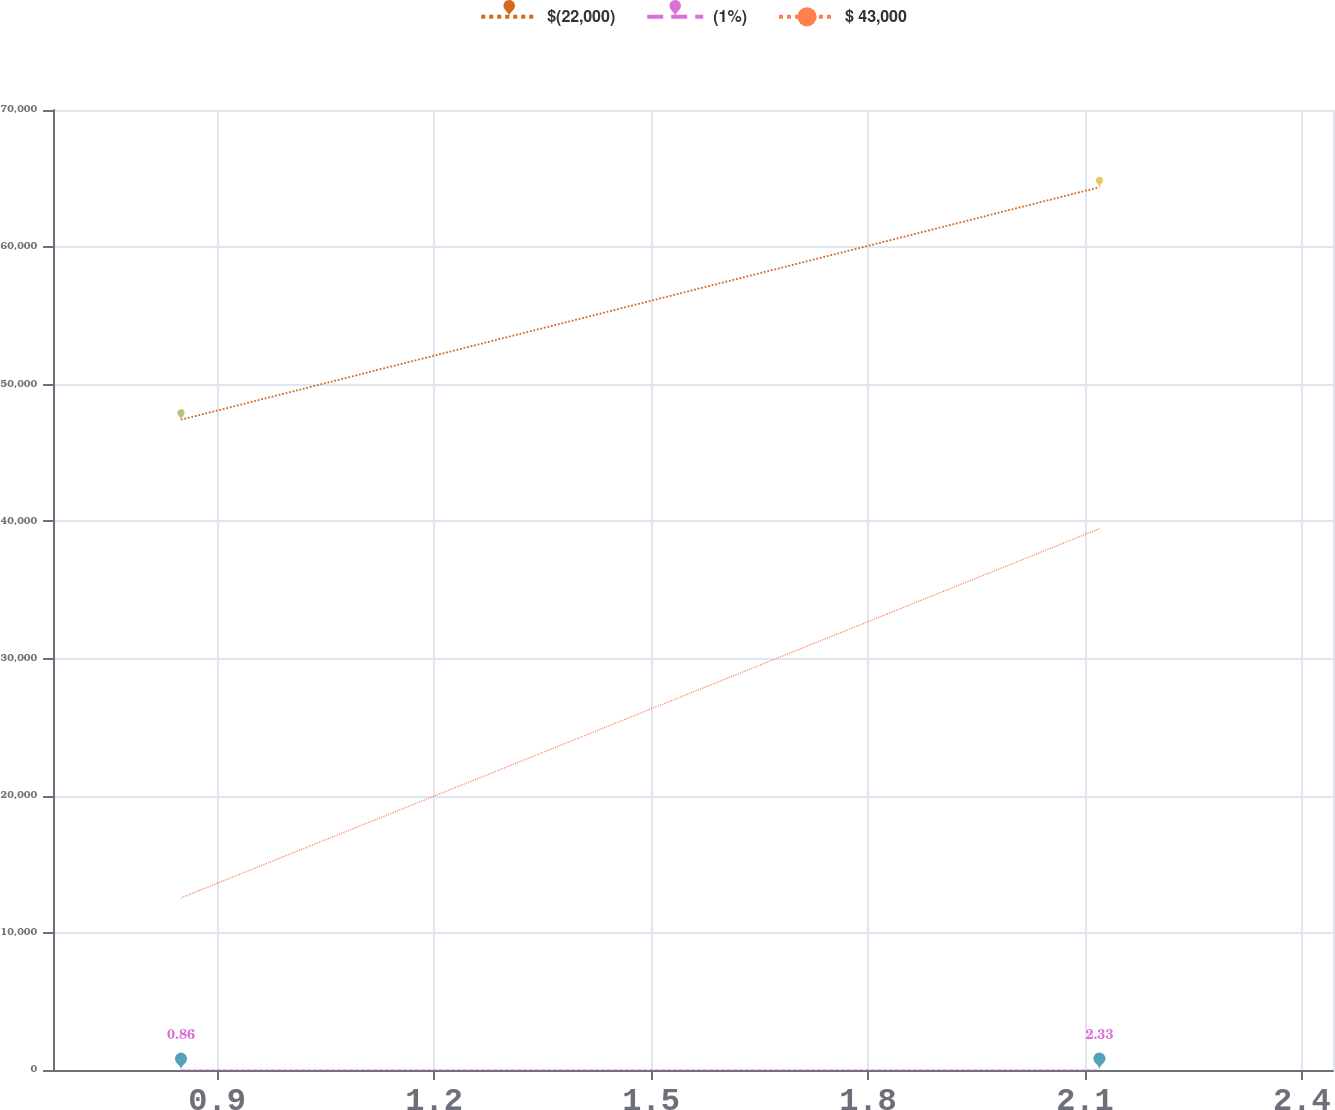Convert chart. <chart><loc_0><loc_0><loc_500><loc_500><line_chart><ecel><fcel>$(22,000)<fcel>(1%)<fcel>$ 43,000<nl><fcel>0.85<fcel>47415.8<fcel>0.86<fcel>12552.5<nl><fcel>2.12<fcel>64367.8<fcel>2.33<fcel>39472.8<nl><fcel>2.62<fcel>129529<fcel>2.52<fcel>43205<nl></chart> 